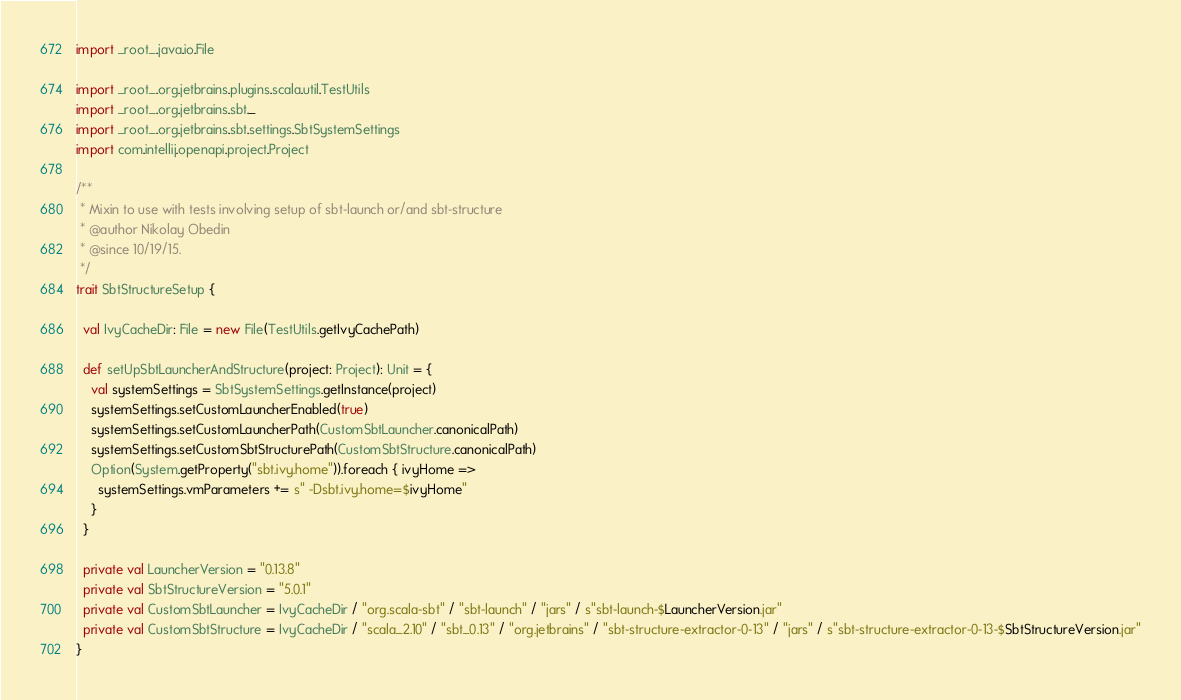Convert code to text. <code><loc_0><loc_0><loc_500><loc_500><_Scala_>
import _root_.java.io.File

import _root_.org.jetbrains.plugins.scala.util.TestUtils
import _root_.org.jetbrains.sbt._
import _root_.org.jetbrains.sbt.settings.SbtSystemSettings
import com.intellij.openapi.project.Project

/**
 * Mixin to use with tests involving setup of sbt-launch or/and sbt-structure
 * @author Nikolay Obedin
 * @since 10/19/15.
 */
trait SbtStructureSetup {

  val IvyCacheDir: File = new File(TestUtils.getIvyCachePath)

  def setUpSbtLauncherAndStructure(project: Project): Unit = {
    val systemSettings = SbtSystemSettings.getInstance(project)
    systemSettings.setCustomLauncherEnabled(true)
    systemSettings.setCustomLauncherPath(CustomSbtLauncher.canonicalPath)
    systemSettings.setCustomSbtStructurePath(CustomSbtStructure.canonicalPath)
    Option(System.getProperty("sbt.ivy.home")).foreach { ivyHome =>
      systemSettings.vmParameters += s" -Dsbt.ivy.home=$ivyHome"
    }
  }

  private val LauncherVersion = "0.13.8"
  private val SbtStructureVersion = "5.0.1"
  private val CustomSbtLauncher = IvyCacheDir / "org.scala-sbt" / "sbt-launch" / "jars" / s"sbt-launch-$LauncherVersion.jar"
  private val CustomSbtStructure = IvyCacheDir / "scala_2.10" / "sbt_0.13" / "org.jetbrains" / "sbt-structure-extractor-0-13" / "jars" / s"sbt-structure-extractor-0-13-$SbtStructureVersion.jar"
}
</code> 